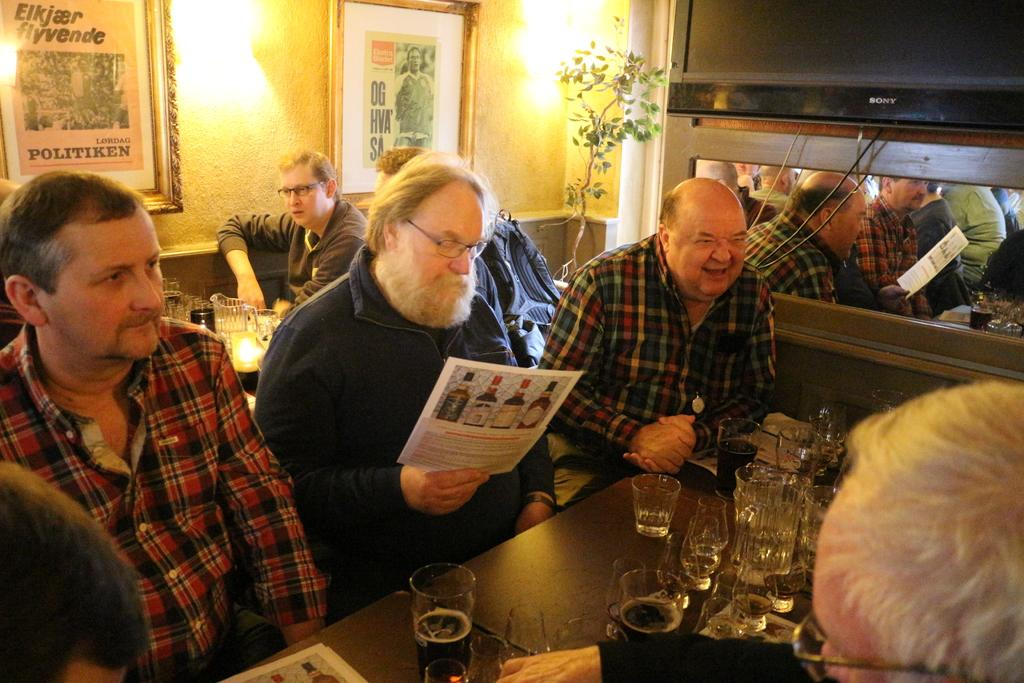How many people are in the group shown in the image? There is a group of persons in the image, but the exact number is not specified. What are the people in the group doing? The group of persons is sitting. What is on the table in the image? There is a table in the image, and it has glasses and drinks on it. What type of test can be seen being conducted at the zoo in the image? There is no test or zoo present in the image; it features a group of sitting persons and a table with glasses and drinks. What color is the sock worn by the person in the image? There is no sock visible in the image. 